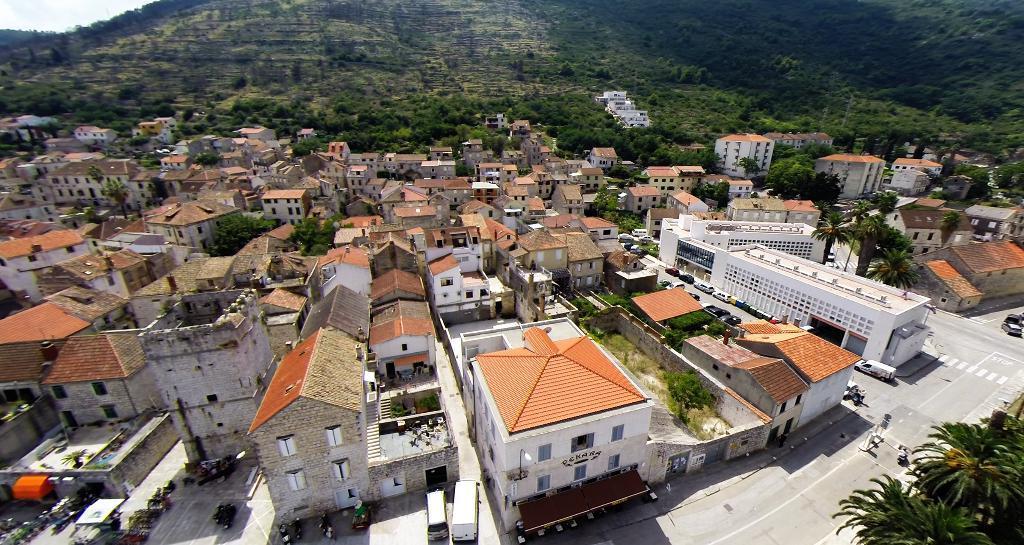In one or two sentences, can you explain what this image depicts? This is the picture of a city. In this image there are buildings, trees and there are vehicles on the road. At the back there is a mountain and there are trees on the mountain. At the top there is sky. At the bottom there is a road. 